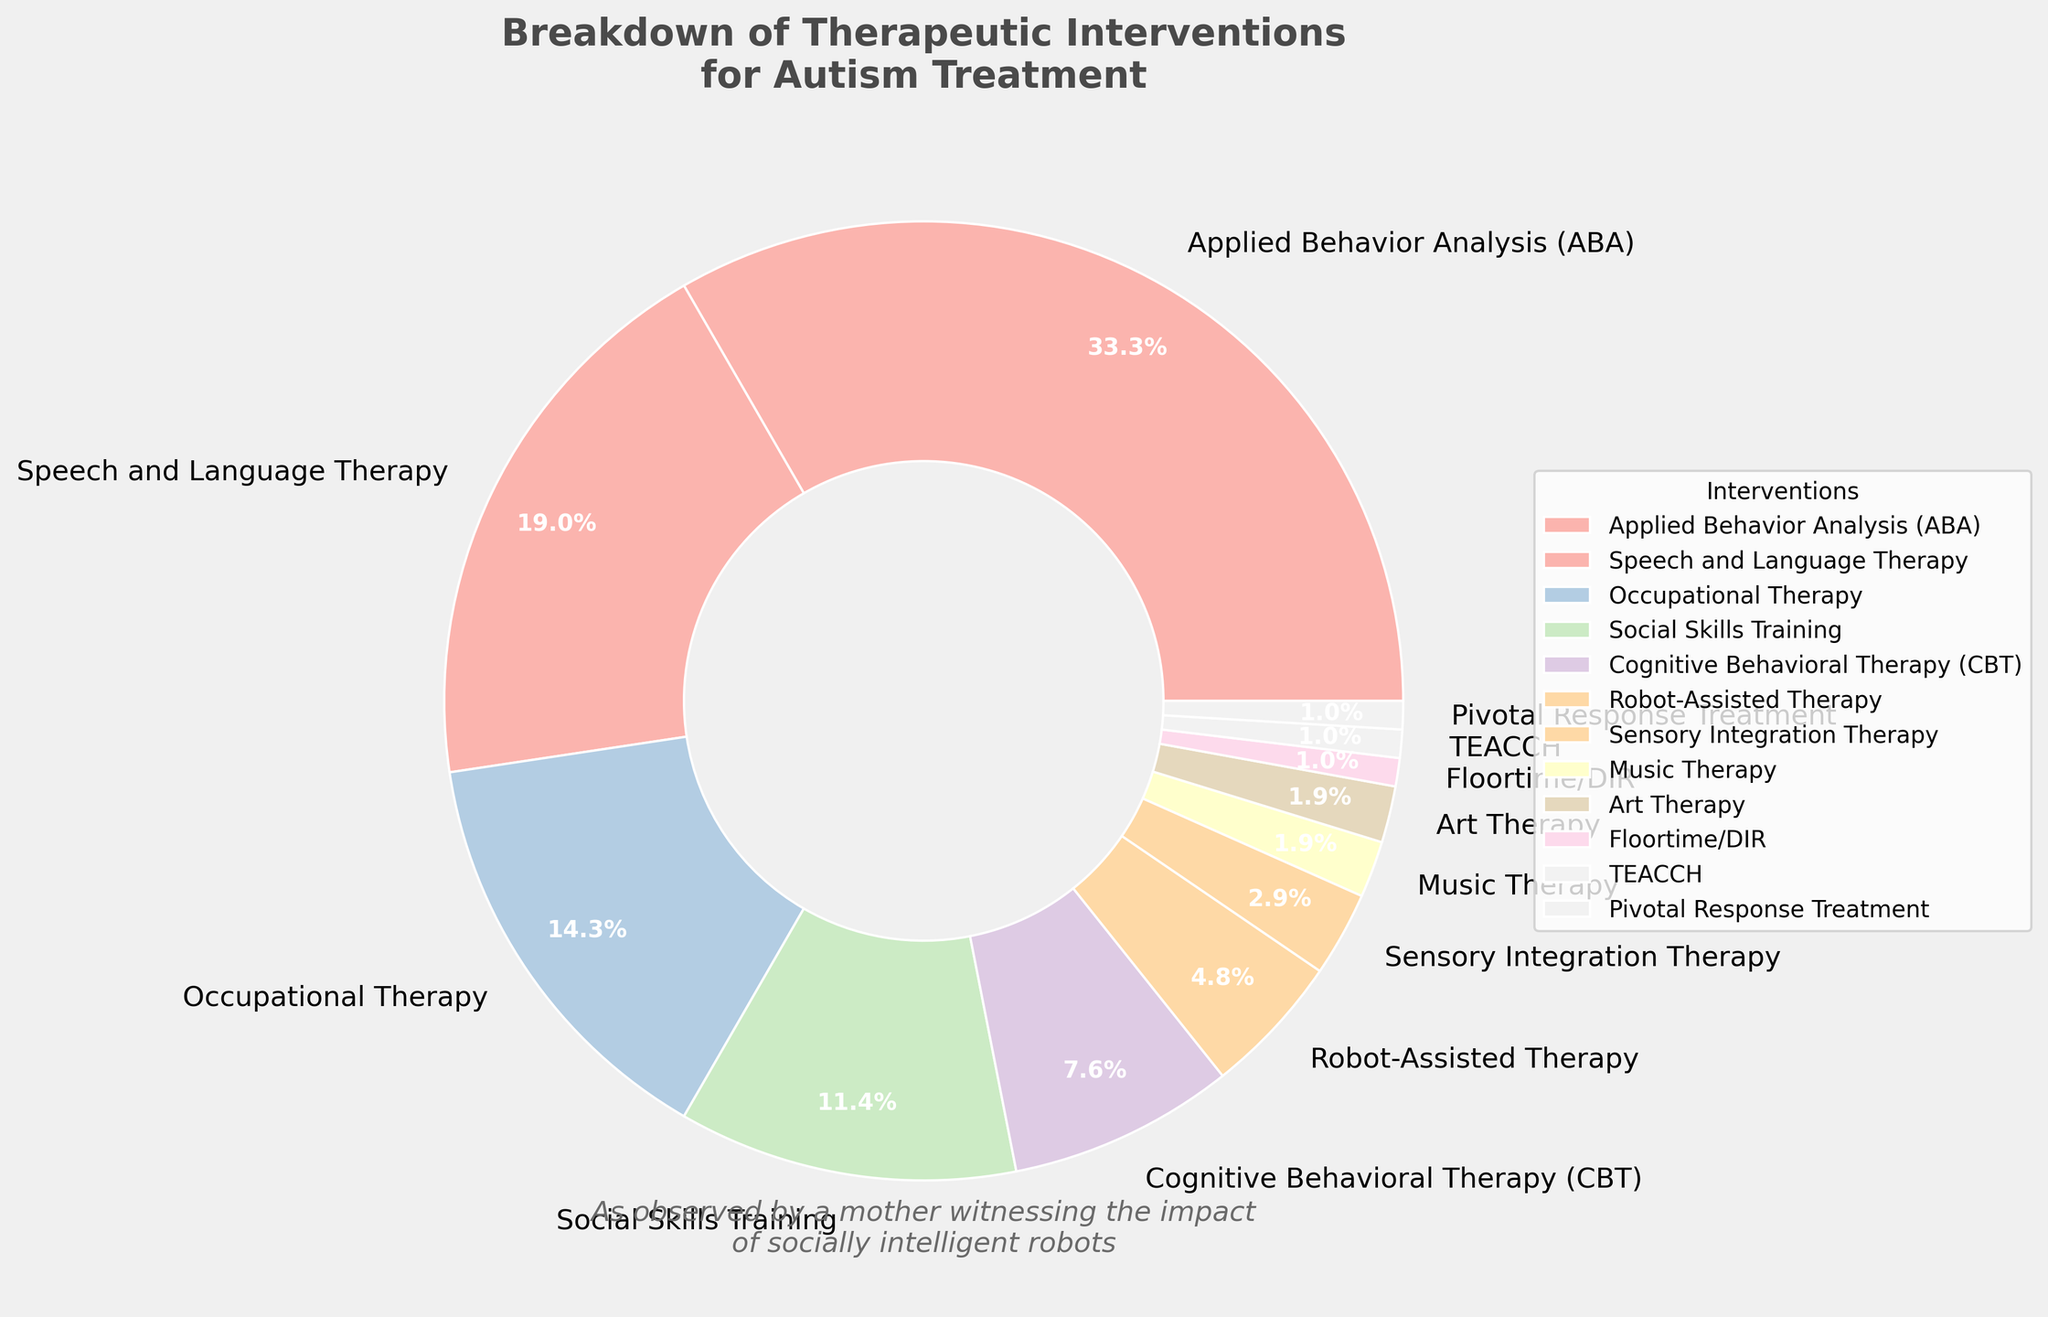What percentage of the pie chart is comprised of Cognitive Behavioral Therapy (CBT) and Art Therapy combined? Find the percentage for both Cognitive Behavioral Therapy (CBT) and Art Therapy from the pie chart. Then, add these percentages together: 8% (CBT) + 2% (Art Therapy) = 10%
Answer: 10% Which therapeutic intervention has the highest percentage, and what is that percentage? Identify the segment of the pie chart that takes up the largest portion. This is the one labeled "Applied Behavior Analysis (ABA)", with a percentage of 35%.
Answer: Applied Behavior Analysis (ABA), 35% What is the difference in percentage between Speech and Language Therapy and Social Skills Training? Find the percentages for Speech and Language Therapy (20%) and Social Skills Training (12%). Subtract the smaller percentage from the larger one: 20% - 12% = 8%.
Answer: 8% How does the percentage of Occupational Therapy compare to that of Robot-Assisted Therapy? Find the percentages for both interventions: Occupational Therapy is 15% and Robot-Assisted Therapy is 5%. Occupational Therapy has a higher percentage than Robot-Assisted Therapy.
Answer: Occupational Therapy is higher than Robot-Assisted Therapy Which interventions are represented by the smallest sections of the pie chart, and what are their respective percentages? Identify the segments with the smallest percentages, which are "Floortime/DIR" (1%), "TEACCH" (1%), and "Pivotal Response Treatment" (1%).
Answer: Floortime/DIR, TEACCH, and Pivotal Response Treatment, all 1% What is the combined percentage of interventions that are less than or equal to 5% each? Identify the interventions with percentages less than or equal to 5% and add them up: 
Robot-Assisted Therapy (5%) + Sensory Integration Therapy (3%) + Music Therapy (2%) + Art Therapy (2%) + Floortime/DIR (1%) + TEACCH (1%) + Pivotal Response Treatment (1%) = 15%.
Answer: 15% What visual attributes can be used to easily distinguish between different interventions on the pie chart? The pie chart uses different colors to distinguish between interventions. Each segment also has a label with the intervention name and percentage for easier identification.
Answer: Different colors and labels How much more percentage does Applied Behavior Analysis (ABA) have compared to Cognitive Behavioral Therapy (CBT)? Find the percentages for both interventions: Applied Behavior Analysis (ABA) is 35%, and Cognitive Behavioral Therapy (CBT) is 8%. Subtract the smaller percentage from the larger one: 35% - 8% = 27%.
Answer: 27% 